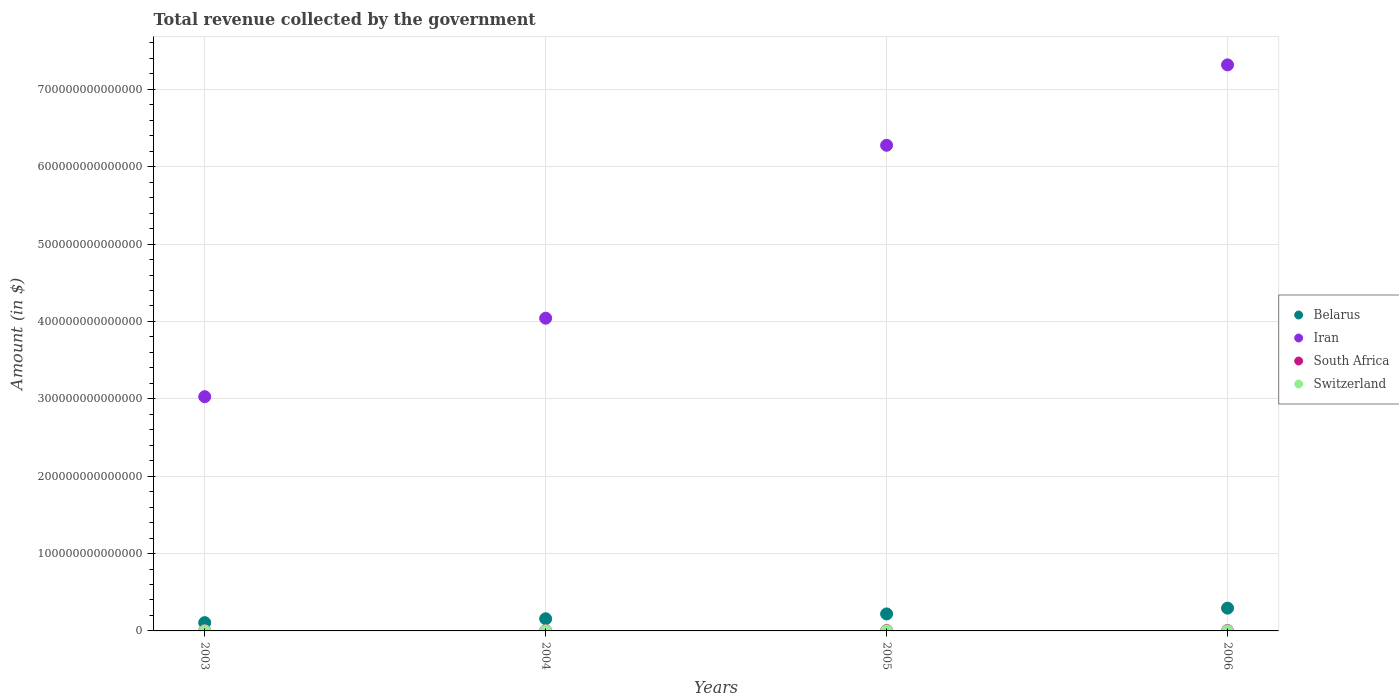Is the number of dotlines equal to the number of legend labels?
Your answer should be very brief. Yes. What is the total revenue collected by the government in Switzerland in 2004?
Offer a terse response. 8.10e+1. Across all years, what is the maximum total revenue collected by the government in Iran?
Ensure brevity in your answer.  7.32e+14. Across all years, what is the minimum total revenue collected by the government in Switzerland?
Make the answer very short. 8.01e+1. What is the total total revenue collected by the government in Iran in the graph?
Make the answer very short. 2.07e+15. What is the difference between the total revenue collected by the government in Iran in 2004 and that in 2005?
Provide a succinct answer. -2.23e+14. What is the difference between the total revenue collected by the government in Switzerland in 2006 and the total revenue collected by the government in South Africa in 2004?
Offer a terse response. -3.09e+11. What is the average total revenue collected by the government in South Africa per year?
Your answer should be compact. 4.41e+11. In the year 2005, what is the difference between the total revenue collected by the government in Switzerland and total revenue collected by the government in South Africa?
Provide a short and direct response. -3.88e+11. What is the ratio of the total revenue collected by the government in Belarus in 2003 to that in 2005?
Your answer should be very brief. 0.49. Is the total revenue collected by the government in Switzerland in 2005 less than that in 2006?
Your answer should be very brief. Yes. Is the difference between the total revenue collected by the government in Switzerland in 2003 and 2006 greater than the difference between the total revenue collected by the government in South Africa in 2003 and 2006?
Provide a succinct answer. Yes. What is the difference between the highest and the second highest total revenue collected by the government in Iran?
Offer a terse response. 1.04e+14. What is the difference between the highest and the lowest total revenue collected by the government in Belarus?
Ensure brevity in your answer.  1.87e+13. In how many years, is the total revenue collected by the government in Belarus greater than the average total revenue collected by the government in Belarus taken over all years?
Ensure brevity in your answer.  2. Is it the case that in every year, the sum of the total revenue collected by the government in Belarus and total revenue collected by the government in South Africa  is greater than the sum of total revenue collected by the government in Switzerland and total revenue collected by the government in Iran?
Make the answer very short. Yes. Is it the case that in every year, the sum of the total revenue collected by the government in Belarus and total revenue collected by the government in Iran  is greater than the total revenue collected by the government in Switzerland?
Provide a short and direct response. Yes. Is the total revenue collected by the government in Iran strictly greater than the total revenue collected by the government in South Africa over the years?
Ensure brevity in your answer.  Yes. How many dotlines are there?
Make the answer very short. 4. What is the difference between two consecutive major ticks on the Y-axis?
Your response must be concise. 1.00e+14. Does the graph contain any zero values?
Your response must be concise. No. Does the graph contain grids?
Offer a very short reply. Yes. Where does the legend appear in the graph?
Provide a succinct answer. Center right. What is the title of the graph?
Provide a succinct answer. Total revenue collected by the government. What is the label or title of the Y-axis?
Keep it short and to the point. Amount (in $). What is the Amount (in $) in Belarus in 2003?
Offer a very short reply. 1.07e+13. What is the Amount (in $) in Iran in 2003?
Provide a succinct answer. 3.03e+14. What is the Amount (in $) in South Africa in 2003?
Offer a very short reply. 3.38e+11. What is the Amount (in $) in Switzerland in 2003?
Offer a very short reply. 8.01e+1. What is the Amount (in $) of Belarus in 2004?
Your answer should be compact. 1.57e+13. What is the Amount (in $) of Iran in 2004?
Your answer should be very brief. 4.04e+14. What is the Amount (in $) in South Africa in 2004?
Your answer should be compact. 3.98e+11. What is the Amount (in $) of Switzerland in 2004?
Your answer should be compact. 8.10e+1. What is the Amount (in $) of Belarus in 2005?
Offer a terse response. 2.20e+13. What is the Amount (in $) of Iran in 2005?
Offer a terse response. 6.28e+14. What is the Amount (in $) of South Africa in 2005?
Ensure brevity in your answer.  4.73e+11. What is the Amount (in $) in Switzerland in 2005?
Your answer should be very brief. 8.44e+1. What is the Amount (in $) in Belarus in 2006?
Provide a short and direct response. 2.94e+13. What is the Amount (in $) in Iran in 2006?
Keep it short and to the point. 7.32e+14. What is the Amount (in $) of South Africa in 2006?
Give a very brief answer. 5.54e+11. What is the Amount (in $) in Switzerland in 2006?
Keep it short and to the point. 8.91e+1. Across all years, what is the maximum Amount (in $) in Belarus?
Provide a short and direct response. 2.94e+13. Across all years, what is the maximum Amount (in $) of Iran?
Make the answer very short. 7.32e+14. Across all years, what is the maximum Amount (in $) of South Africa?
Provide a succinct answer. 5.54e+11. Across all years, what is the maximum Amount (in $) in Switzerland?
Offer a terse response. 8.91e+1. Across all years, what is the minimum Amount (in $) of Belarus?
Keep it short and to the point. 1.07e+13. Across all years, what is the minimum Amount (in $) of Iran?
Ensure brevity in your answer.  3.03e+14. Across all years, what is the minimum Amount (in $) of South Africa?
Provide a short and direct response. 3.38e+11. Across all years, what is the minimum Amount (in $) of Switzerland?
Your answer should be compact. 8.01e+1. What is the total Amount (in $) of Belarus in the graph?
Give a very brief answer. 7.79e+13. What is the total Amount (in $) of Iran in the graph?
Provide a succinct answer. 2.07e+15. What is the total Amount (in $) of South Africa in the graph?
Your answer should be very brief. 1.76e+12. What is the total Amount (in $) in Switzerland in the graph?
Provide a short and direct response. 3.35e+11. What is the difference between the Amount (in $) in Belarus in 2003 and that in 2004?
Provide a short and direct response. -4.99e+12. What is the difference between the Amount (in $) in Iran in 2003 and that in 2004?
Offer a very short reply. -1.01e+14. What is the difference between the Amount (in $) of South Africa in 2003 and that in 2004?
Ensure brevity in your answer.  -5.96e+1. What is the difference between the Amount (in $) of Switzerland in 2003 and that in 2004?
Your response must be concise. -8.52e+08. What is the difference between the Amount (in $) in Belarus in 2003 and that in 2005?
Offer a terse response. -1.13e+13. What is the difference between the Amount (in $) of Iran in 2003 and that in 2005?
Give a very brief answer. -3.25e+14. What is the difference between the Amount (in $) in South Africa in 2003 and that in 2005?
Make the answer very short. -1.34e+11. What is the difference between the Amount (in $) in Switzerland in 2003 and that in 2005?
Give a very brief answer. -4.27e+09. What is the difference between the Amount (in $) in Belarus in 2003 and that in 2006?
Offer a very short reply. -1.87e+13. What is the difference between the Amount (in $) in Iran in 2003 and that in 2006?
Make the answer very short. -4.29e+14. What is the difference between the Amount (in $) of South Africa in 2003 and that in 2006?
Offer a terse response. -2.16e+11. What is the difference between the Amount (in $) of Switzerland in 2003 and that in 2006?
Provide a short and direct response. -9.02e+09. What is the difference between the Amount (in $) in Belarus in 2004 and that in 2005?
Ensure brevity in your answer.  -6.26e+12. What is the difference between the Amount (in $) of Iran in 2004 and that in 2005?
Ensure brevity in your answer.  -2.23e+14. What is the difference between the Amount (in $) in South Africa in 2004 and that in 2005?
Ensure brevity in your answer.  -7.47e+1. What is the difference between the Amount (in $) in Switzerland in 2004 and that in 2005?
Provide a short and direct response. -3.42e+09. What is the difference between the Amount (in $) of Belarus in 2004 and that in 2006?
Give a very brief answer. -1.37e+13. What is the difference between the Amount (in $) in Iran in 2004 and that in 2006?
Make the answer very short. -3.27e+14. What is the difference between the Amount (in $) in South Africa in 2004 and that in 2006?
Your response must be concise. -1.56e+11. What is the difference between the Amount (in $) in Switzerland in 2004 and that in 2006?
Give a very brief answer. -8.16e+09. What is the difference between the Amount (in $) in Belarus in 2005 and that in 2006?
Provide a short and direct response. -7.47e+12. What is the difference between the Amount (in $) of Iran in 2005 and that in 2006?
Your answer should be very brief. -1.04e+14. What is the difference between the Amount (in $) in South Africa in 2005 and that in 2006?
Offer a very short reply. -8.14e+1. What is the difference between the Amount (in $) in Switzerland in 2005 and that in 2006?
Ensure brevity in your answer.  -4.74e+09. What is the difference between the Amount (in $) of Belarus in 2003 and the Amount (in $) of Iran in 2004?
Give a very brief answer. -3.93e+14. What is the difference between the Amount (in $) in Belarus in 2003 and the Amount (in $) in South Africa in 2004?
Ensure brevity in your answer.  1.03e+13. What is the difference between the Amount (in $) in Belarus in 2003 and the Amount (in $) in Switzerland in 2004?
Give a very brief answer. 1.06e+13. What is the difference between the Amount (in $) of Iran in 2003 and the Amount (in $) of South Africa in 2004?
Keep it short and to the point. 3.02e+14. What is the difference between the Amount (in $) in Iran in 2003 and the Amount (in $) in Switzerland in 2004?
Make the answer very short. 3.03e+14. What is the difference between the Amount (in $) in South Africa in 2003 and the Amount (in $) in Switzerland in 2004?
Your answer should be compact. 2.57e+11. What is the difference between the Amount (in $) of Belarus in 2003 and the Amount (in $) of Iran in 2005?
Provide a short and direct response. -6.17e+14. What is the difference between the Amount (in $) in Belarus in 2003 and the Amount (in $) in South Africa in 2005?
Provide a succinct answer. 1.02e+13. What is the difference between the Amount (in $) in Belarus in 2003 and the Amount (in $) in Switzerland in 2005?
Offer a very short reply. 1.06e+13. What is the difference between the Amount (in $) of Iran in 2003 and the Amount (in $) of South Africa in 2005?
Provide a short and direct response. 3.02e+14. What is the difference between the Amount (in $) in Iran in 2003 and the Amount (in $) in Switzerland in 2005?
Keep it short and to the point. 3.03e+14. What is the difference between the Amount (in $) of South Africa in 2003 and the Amount (in $) of Switzerland in 2005?
Provide a succinct answer. 2.54e+11. What is the difference between the Amount (in $) in Belarus in 2003 and the Amount (in $) in Iran in 2006?
Offer a very short reply. -7.21e+14. What is the difference between the Amount (in $) in Belarus in 2003 and the Amount (in $) in South Africa in 2006?
Your response must be concise. 1.02e+13. What is the difference between the Amount (in $) in Belarus in 2003 and the Amount (in $) in Switzerland in 2006?
Ensure brevity in your answer.  1.06e+13. What is the difference between the Amount (in $) in Iran in 2003 and the Amount (in $) in South Africa in 2006?
Make the answer very short. 3.02e+14. What is the difference between the Amount (in $) of Iran in 2003 and the Amount (in $) of Switzerland in 2006?
Your answer should be very brief. 3.03e+14. What is the difference between the Amount (in $) in South Africa in 2003 and the Amount (in $) in Switzerland in 2006?
Ensure brevity in your answer.  2.49e+11. What is the difference between the Amount (in $) in Belarus in 2004 and the Amount (in $) in Iran in 2005?
Offer a very short reply. -6.12e+14. What is the difference between the Amount (in $) of Belarus in 2004 and the Amount (in $) of South Africa in 2005?
Provide a succinct answer. 1.52e+13. What is the difference between the Amount (in $) in Belarus in 2004 and the Amount (in $) in Switzerland in 2005?
Provide a succinct answer. 1.56e+13. What is the difference between the Amount (in $) of Iran in 2004 and the Amount (in $) of South Africa in 2005?
Make the answer very short. 4.04e+14. What is the difference between the Amount (in $) in Iran in 2004 and the Amount (in $) in Switzerland in 2005?
Make the answer very short. 4.04e+14. What is the difference between the Amount (in $) of South Africa in 2004 and the Amount (in $) of Switzerland in 2005?
Ensure brevity in your answer.  3.14e+11. What is the difference between the Amount (in $) in Belarus in 2004 and the Amount (in $) in Iran in 2006?
Offer a very short reply. -7.16e+14. What is the difference between the Amount (in $) in Belarus in 2004 and the Amount (in $) in South Africa in 2006?
Offer a terse response. 1.52e+13. What is the difference between the Amount (in $) in Belarus in 2004 and the Amount (in $) in Switzerland in 2006?
Make the answer very short. 1.56e+13. What is the difference between the Amount (in $) of Iran in 2004 and the Amount (in $) of South Africa in 2006?
Keep it short and to the point. 4.04e+14. What is the difference between the Amount (in $) of Iran in 2004 and the Amount (in $) of Switzerland in 2006?
Offer a very short reply. 4.04e+14. What is the difference between the Amount (in $) of South Africa in 2004 and the Amount (in $) of Switzerland in 2006?
Offer a terse response. 3.09e+11. What is the difference between the Amount (in $) in Belarus in 2005 and the Amount (in $) in Iran in 2006?
Offer a very short reply. -7.10e+14. What is the difference between the Amount (in $) of Belarus in 2005 and the Amount (in $) of South Africa in 2006?
Keep it short and to the point. 2.14e+13. What is the difference between the Amount (in $) of Belarus in 2005 and the Amount (in $) of Switzerland in 2006?
Ensure brevity in your answer.  2.19e+13. What is the difference between the Amount (in $) in Iran in 2005 and the Amount (in $) in South Africa in 2006?
Make the answer very short. 6.27e+14. What is the difference between the Amount (in $) in Iran in 2005 and the Amount (in $) in Switzerland in 2006?
Your answer should be very brief. 6.28e+14. What is the difference between the Amount (in $) in South Africa in 2005 and the Amount (in $) in Switzerland in 2006?
Offer a terse response. 3.84e+11. What is the average Amount (in $) of Belarus per year?
Ensure brevity in your answer.  1.95e+13. What is the average Amount (in $) of Iran per year?
Your answer should be very brief. 5.17e+14. What is the average Amount (in $) of South Africa per year?
Make the answer very short. 4.41e+11. What is the average Amount (in $) in Switzerland per year?
Make the answer very short. 8.37e+1. In the year 2003, what is the difference between the Amount (in $) in Belarus and Amount (in $) in Iran?
Offer a terse response. -2.92e+14. In the year 2003, what is the difference between the Amount (in $) of Belarus and Amount (in $) of South Africa?
Give a very brief answer. 1.04e+13. In the year 2003, what is the difference between the Amount (in $) of Belarus and Amount (in $) of Switzerland?
Provide a short and direct response. 1.06e+13. In the year 2003, what is the difference between the Amount (in $) in Iran and Amount (in $) in South Africa?
Your answer should be very brief. 3.02e+14. In the year 2003, what is the difference between the Amount (in $) in Iran and Amount (in $) in Switzerland?
Your answer should be very brief. 3.03e+14. In the year 2003, what is the difference between the Amount (in $) of South Africa and Amount (in $) of Switzerland?
Offer a very short reply. 2.58e+11. In the year 2004, what is the difference between the Amount (in $) in Belarus and Amount (in $) in Iran?
Your answer should be very brief. -3.88e+14. In the year 2004, what is the difference between the Amount (in $) in Belarus and Amount (in $) in South Africa?
Provide a short and direct response. 1.53e+13. In the year 2004, what is the difference between the Amount (in $) in Belarus and Amount (in $) in Switzerland?
Your answer should be compact. 1.56e+13. In the year 2004, what is the difference between the Amount (in $) in Iran and Amount (in $) in South Africa?
Your answer should be very brief. 4.04e+14. In the year 2004, what is the difference between the Amount (in $) in Iran and Amount (in $) in Switzerland?
Your response must be concise. 4.04e+14. In the year 2004, what is the difference between the Amount (in $) of South Africa and Amount (in $) of Switzerland?
Your answer should be very brief. 3.17e+11. In the year 2005, what is the difference between the Amount (in $) in Belarus and Amount (in $) in Iran?
Your answer should be compact. -6.06e+14. In the year 2005, what is the difference between the Amount (in $) in Belarus and Amount (in $) in South Africa?
Your response must be concise. 2.15e+13. In the year 2005, what is the difference between the Amount (in $) of Belarus and Amount (in $) of Switzerland?
Your answer should be very brief. 2.19e+13. In the year 2005, what is the difference between the Amount (in $) of Iran and Amount (in $) of South Africa?
Provide a short and direct response. 6.27e+14. In the year 2005, what is the difference between the Amount (in $) of Iran and Amount (in $) of Switzerland?
Your answer should be very brief. 6.28e+14. In the year 2005, what is the difference between the Amount (in $) of South Africa and Amount (in $) of Switzerland?
Your answer should be compact. 3.88e+11. In the year 2006, what is the difference between the Amount (in $) in Belarus and Amount (in $) in Iran?
Give a very brief answer. -7.02e+14. In the year 2006, what is the difference between the Amount (in $) of Belarus and Amount (in $) of South Africa?
Provide a succinct answer. 2.89e+13. In the year 2006, what is the difference between the Amount (in $) in Belarus and Amount (in $) in Switzerland?
Offer a very short reply. 2.94e+13. In the year 2006, what is the difference between the Amount (in $) in Iran and Amount (in $) in South Africa?
Offer a very short reply. 7.31e+14. In the year 2006, what is the difference between the Amount (in $) of Iran and Amount (in $) of Switzerland?
Make the answer very short. 7.31e+14. In the year 2006, what is the difference between the Amount (in $) in South Africa and Amount (in $) in Switzerland?
Keep it short and to the point. 4.65e+11. What is the ratio of the Amount (in $) of Belarus in 2003 to that in 2004?
Keep it short and to the point. 0.68. What is the ratio of the Amount (in $) in Iran in 2003 to that in 2004?
Provide a succinct answer. 0.75. What is the ratio of the Amount (in $) in South Africa in 2003 to that in 2004?
Offer a very short reply. 0.85. What is the ratio of the Amount (in $) in Switzerland in 2003 to that in 2004?
Provide a short and direct response. 0.99. What is the ratio of the Amount (in $) in Belarus in 2003 to that in 2005?
Offer a terse response. 0.49. What is the ratio of the Amount (in $) in Iran in 2003 to that in 2005?
Your answer should be very brief. 0.48. What is the ratio of the Amount (in $) in South Africa in 2003 to that in 2005?
Keep it short and to the point. 0.72. What is the ratio of the Amount (in $) of Switzerland in 2003 to that in 2005?
Provide a succinct answer. 0.95. What is the ratio of the Amount (in $) of Belarus in 2003 to that in 2006?
Keep it short and to the point. 0.36. What is the ratio of the Amount (in $) of Iran in 2003 to that in 2006?
Provide a short and direct response. 0.41. What is the ratio of the Amount (in $) of South Africa in 2003 to that in 2006?
Ensure brevity in your answer.  0.61. What is the ratio of the Amount (in $) in Switzerland in 2003 to that in 2006?
Offer a very short reply. 0.9. What is the ratio of the Amount (in $) of Belarus in 2004 to that in 2005?
Ensure brevity in your answer.  0.71. What is the ratio of the Amount (in $) in Iran in 2004 to that in 2005?
Your response must be concise. 0.64. What is the ratio of the Amount (in $) of South Africa in 2004 to that in 2005?
Make the answer very short. 0.84. What is the ratio of the Amount (in $) of Switzerland in 2004 to that in 2005?
Your response must be concise. 0.96. What is the ratio of the Amount (in $) in Belarus in 2004 to that in 2006?
Keep it short and to the point. 0.53. What is the ratio of the Amount (in $) in Iran in 2004 to that in 2006?
Offer a very short reply. 0.55. What is the ratio of the Amount (in $) of South Africa in 2004 to that in 2006?
Make the answer very short. 0.72. What is the ratio of the Amount (in $) of Switzerland in 2004 to that in 2006?
Your answer should be compact. 0.91. What is the ratio of the Amount (in $) of Belarus in 2005 to that in 2006?
Offer a terse response. 0.75. What is the ratio of the Amount (in $) of Iran in 2005 to that in 2006?
Provide a short and direct response. 0.86. What is the ratio of the Amount (in $) of South Africa in 2005 to that in 2006?
Offer a terse response. 0.85. What is the ratio of the Amount (in $) of Switzerland in 2005 to that in 2006?
Your answer should be very brief. 0.95. What is the difference between the highest and the second highest Amount (in $) in Belarus?
Offer a terse response. 7.47e+12. What is the difference between the highest and the second highest Amount (in $) of Iran?
Your answer should be compact. 1.04e+14. What is the difference between the highest and the second highest Amount (in $) of South Africa?
Make the answer very short. 8.14e+1. What is the difference between the highest and the second highest Amount (in $) of Switzerland?
Your answer should be very brief. 4.74e+09. What is the difference between the highest and the lowest Amount (in $) in Belarus?
Offer a very short reply. 1.87e+13. What is the difference between the highest and the lowest Amount (in $) of Iran?
Keep it short and to the point. 4.29e+14. What is the difference between the highest and the lowest Amount (in $) in South Africa?
Provide a succinct answer. 2.16e+11. What is the difference between the highest and the lowest Amount (in $) in Switzerland?
Your answer should be compact. 9.02e+09. 